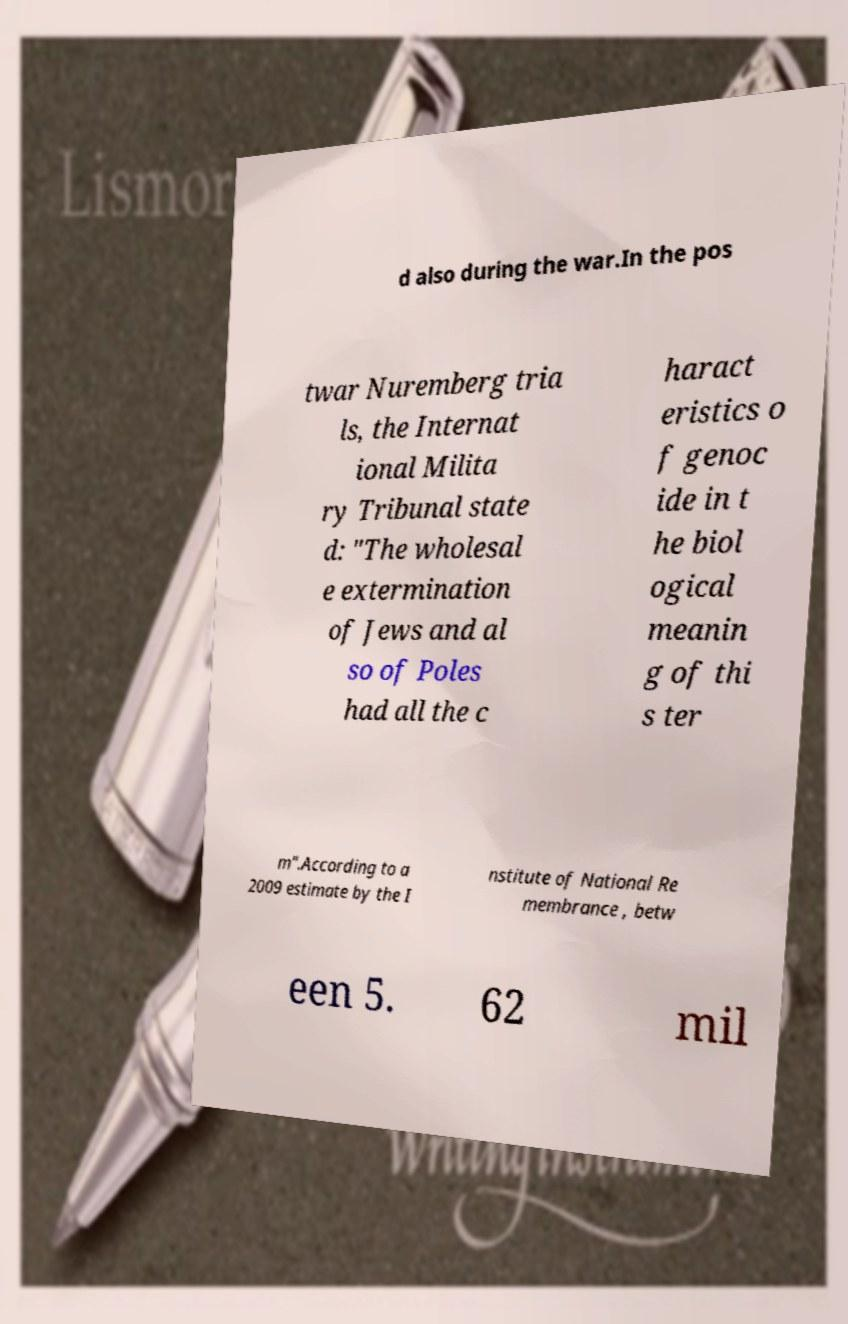Please identify and transcribe the text found in this image. d also during the war.In the pos twar Nuremberg tria ls, the Internat ional Milita ry Tribunal state d: "The wholesal e extermination of Jews and al so of Poles had all the c haract eristics o f genoc ide in t he biol ogical meanin g of thi s ter m".According to a 2009 estimate by the I nstitute of National Re membrance , betw een 5. 62 mil 